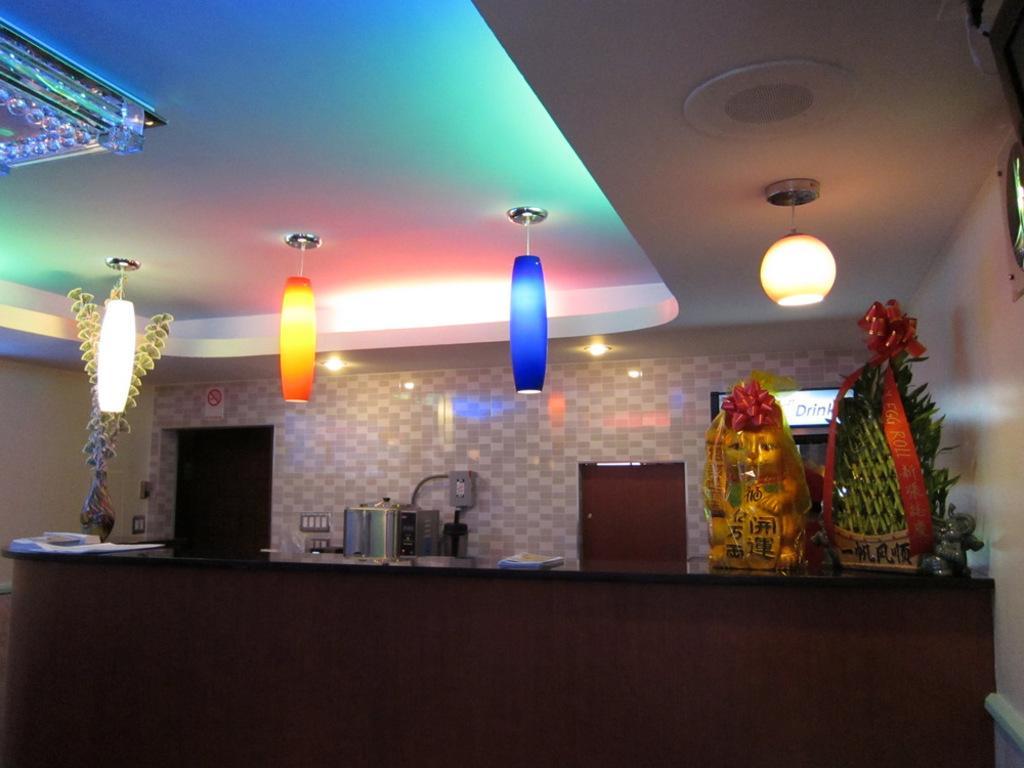Please provide a concise description of this image. In the foreground I can see a cabinet on which I can see kitchen tools, flower vases, bouquets. On the top I can see lamps are hanged. This image is taken in a hall. 